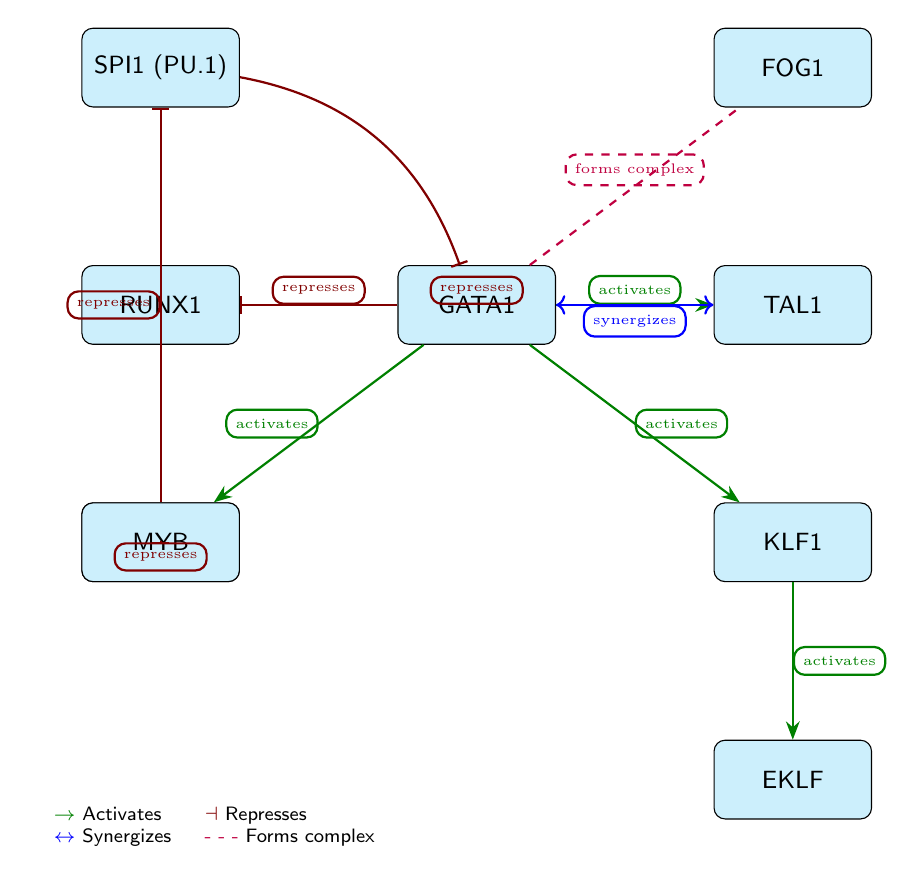What transcription factor does GATA1 repress? GATA1 has a direct relationship indicating a repression toward RUNX1, as shown by the red arrow directed from GATA1 to RUNX1 labeled "represses."
Answer: RUNX1 How many total nodes are present in the diagram? By counting each transcription factor represented as a node, there are 8 nodes total: GATA1, TAL1, KLF1, FOG1, EKLF, GFI1B, RUNX1, and SPI1.
Answer: 8 Which transcription factor forms a complex with GATA1? The diagram shows a dashed line with a label "forms complex" connecting GATA1 and FOG1. This indicates that GATA1 interacts with FOG1 to form a complex.
Answer: FOG1 What is the relationship between GFI1B and SPI1? The diagram depicts a repression relationship where GFI1B sends a red arrow to SPI1, indicating that GFI1B represses SPI1 as labeled in the diagram.
Answer: represses Which transcription factor synergizes with TAL1? The relationship between TAL1 and GATA1 is indicated by a blue double-headed arrow labeled "synergizes," meaning these two transcription factors work together synergistically.
Answer: GATA1 What type of interaction is indicated between MYB and GFI1B? The diagram indicates a repression relationship from MYB to GFI1B, as shown by the red arrow connecting these two nodes with the label "represses."
Answer: represses How many activates relationships are there originating from GATA1? GATA1 has three edges labeled "activates" directed toward TAL1, KLF1, and GFI1B. Therefore, it has three activates relationships originating from it.
Answer: 3 What transcription factor is activated by KLF1? According to the diagram, KLF1 activates EKLF, indicated by a green arrow from KLF1 to EKLF labeled "activates."
Answer: EKLF 